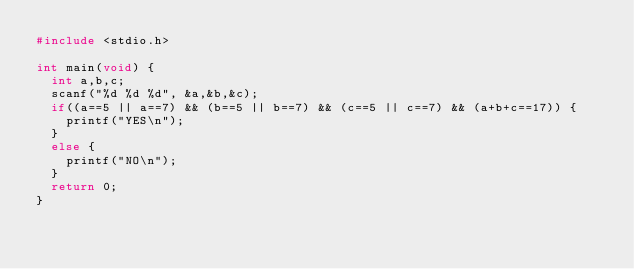Convert code to text. <code><loc_0><loc_0><loc_500><loc_500><_C_>#include <stdio.h>

int main(void) {
  int a,b,c;
  scanf("%d %d %d", &a,&b,&c);
  if((a==5 || a==7) && (b==5 || b==7) && (c==5 || c==7) && (a+b+c==17)) {
    printf("YES\n");
  }
  else {
    printf("NO\n");
  }
  return 0;
}</code> 